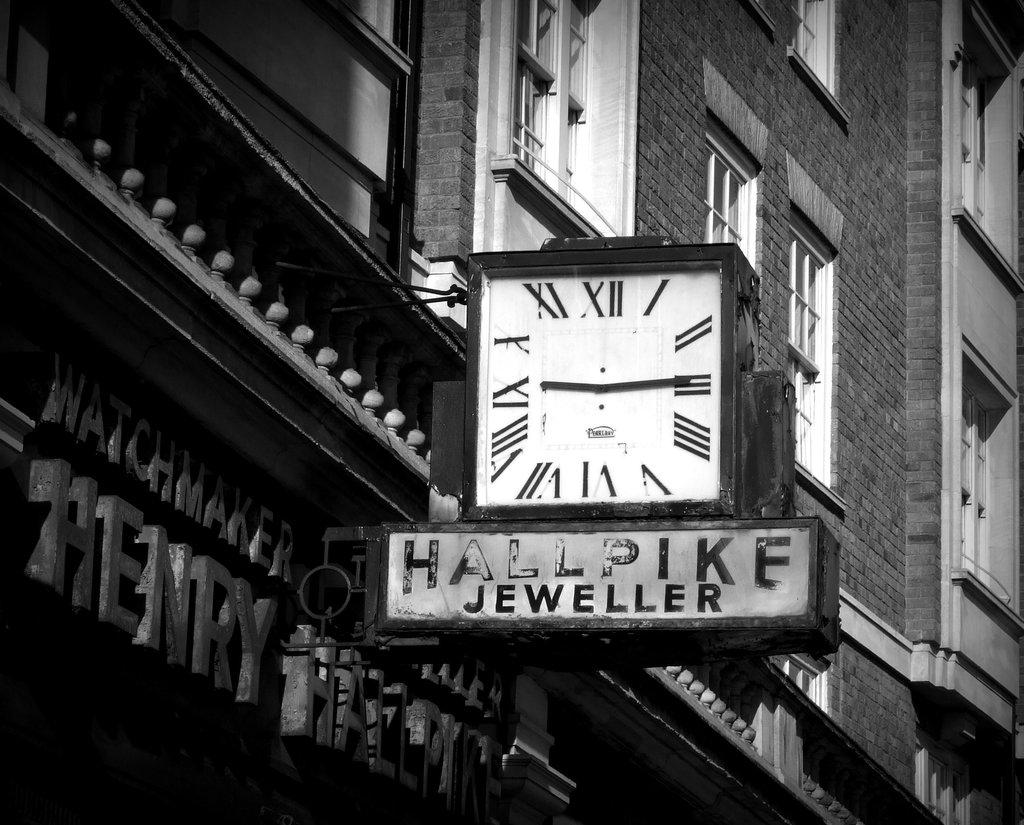What's the name of the jeweller?
Ensure brevity in your answer.  Hallpike. What number does the little hand on the clock point to?
Ensure brevity in your answer.  9. 